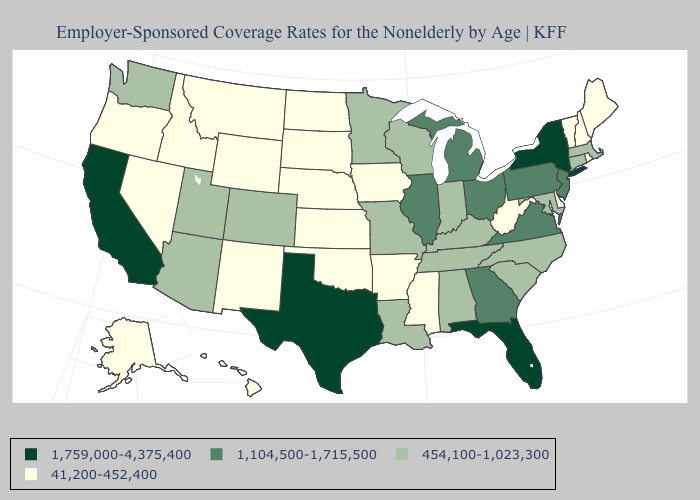Name the states that have a value in the range 41,200-452,400?
Answer briefly. Alaska, Arkansas, Delaware, Hawaii, Idaho, Iowa, Kansas, Maine, Mississippi, Montana, Nebraska, Nevada, New Hampshire, New Mexico, North Dakota, Oklahoma, Oregon, Rhode Island, South Dakota, Vermont, West Virginia, Wyoming. Does Minnesota have the lowest value in the MidWest?
Concise answer only. No. What is the value of South Dakota?
Quick response, please. 41,200-452,400. Name the states that have a value in the range 41,200-452,400?
Keep it brief. Alaska, Arkansas, Delaware, Hawaii, Idaho, Iowa, Kansas, Maine, Mississippi, Montana, Nebraska, Nevada, New Hampshire, New Mexico, North Dakota, Oklahoma, Oregon, Rhode Island, South Dakota, Vermont, West Virginia, Wyoming. Name the states that have a value in the range 41,200-452,400?
Answer briefly. Alaska, Arkansas, Delaware, Hawaii, Idaho, Iowa, Kansas, Maine, Mississippi, Montana, Nebraska, Nevada, New Hampshire, New Mexico, North Dakota, Oklahoma, Oregon, Rhode Island, South Dakota, Vermont, West Virginia, Wyoming. Which states have the lowest value in the USA?
Quick response, please. Alaska, Arkansas, Delaware, Hawaii, Idaho, Iowa, Kansas, Maine, Mississippi, Montana, Nebraska, Nevada, New Hampshire, New Mexico, North Dakota, Oklahoma, Oregon, Rhode Island, South Dakota, Vermont, West Virginia, Wyoming. Is the legend a continuous bar?
Write a very short answer. No. Name the states that have a value in the range 1,759,000-4,375,400?
Quick response, please. California, Florida, New York, Texas. Name the states that have a value in the range 1,104,500-1,715,500?
Write a very short answer. Georgia, Illinois, Michigan, New Jersey, Ohio, Pennsylvania, Virginia. Does Maryland have the same value as Pennsylvania?
Be succinct. No. Does Delaware have a lower value than Tennessee?
Quick response, please. Yes. What is the highest value in the USA?
Concise answer only. 1,759,000-4,375,400. What is the value of Massachusetts?
Write a very short answer. 454,100-1,023,300. What is the value of New York?
Be succinct. 1,759,000-4,375,400. Which states have the lowest value in the USA?
Quick response, please. Alaska, Arkansas, Delaware, Hawaii, Idaho, Iowa, Kansas, Maine, Mississippi, Montana, Nebraska, Nevada, New Hampshire, New Mexico, North Dakota, Oklahoma, Oregon, Rhode Island, South Dakota, Vermont, West Virginia, Wyoming. 